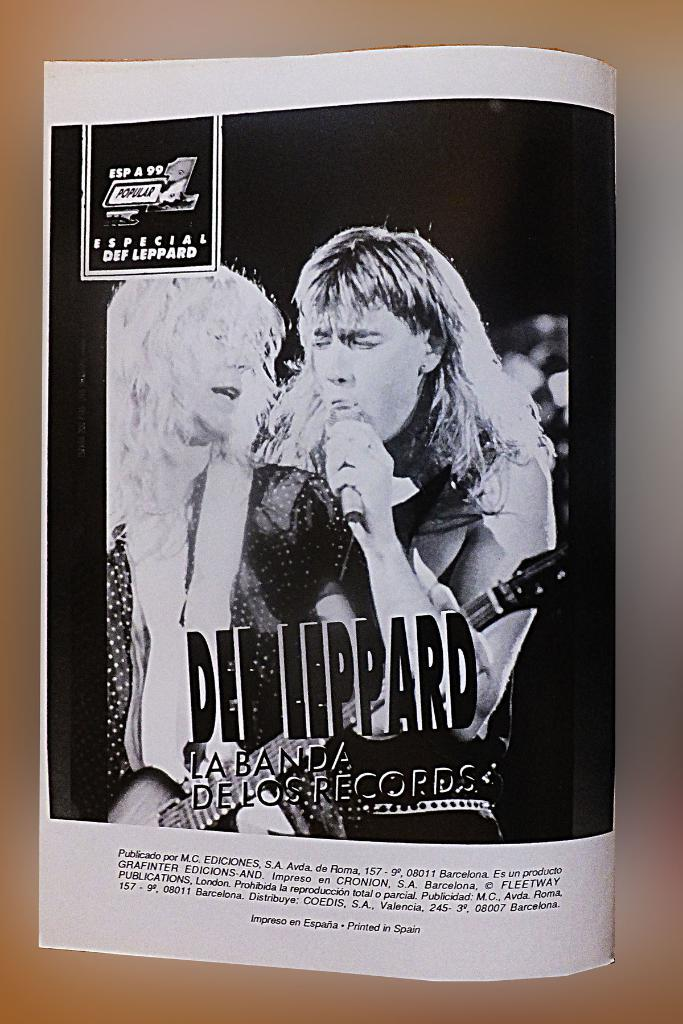<image>
Relay a brief, clear account of the picture shown. Page of a book showing two men singing titled "Def Leppard". 